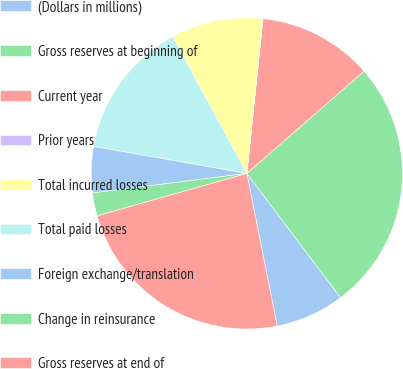Convert chart. <chart><loc_0><loc_0><loc_500><loc_500><pie_chart><fcel>(Dollars in millions)<fcel>Gross reserves at beginning of<fcel>Current year<fcel>Prior years<fcel>Total incurred losses<fcel>Total paid losses<fcel>Foreign exchange/translation<fcel>Change in reinsurance<fcel>Gross reserves at end of<nl><fcel>7.16%<fcel>26.12%<fcel>11.93%<fcel>0.01%<fcel>9.55%<fcel>14.32%<fcel>4.78%<fcel>2.39%<fcel>23.73%<nl></chart> 